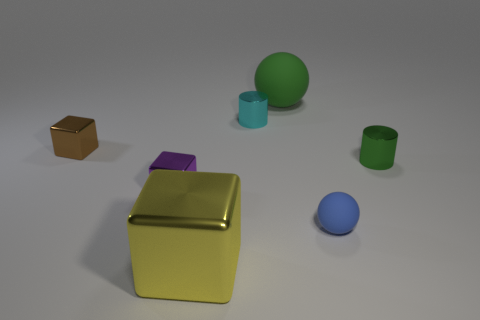The tiny green object that is the same material as the cyan cylinder is what shape?
Make the answer very short. Cylinder. Is the tiny purple shiny object the same shape as the large shiny thing?
Offer a very short reply. Yes. The tiny rubber sphere has what color?
Keep it short and to the point. Blue. How many things are either tiny blue things or large green objects?
Provide a short and direct response. 2. Are there fewer matte spheres that are behind the small green thing than blue matte cylinders?
Your answer should be compact. No. Are there more green metallic things that are in front of the brown block than small blue rubber things that are in front of the large yellow thing?
Offer a terse response. Yes. Is there anything else that has the same color as the small rubber sphere?
Provide a short and direct response. No. There is a tiny cube in front of the green cylinder; what material is it?
Ensure brevity in your answer.  Metal. Do the yellow thing and the green matte thing have the same size?
Provide a succinct answer. Yes. How many other objects are the same size as the green shiny cylinder?
Make the answer very short. 4. 